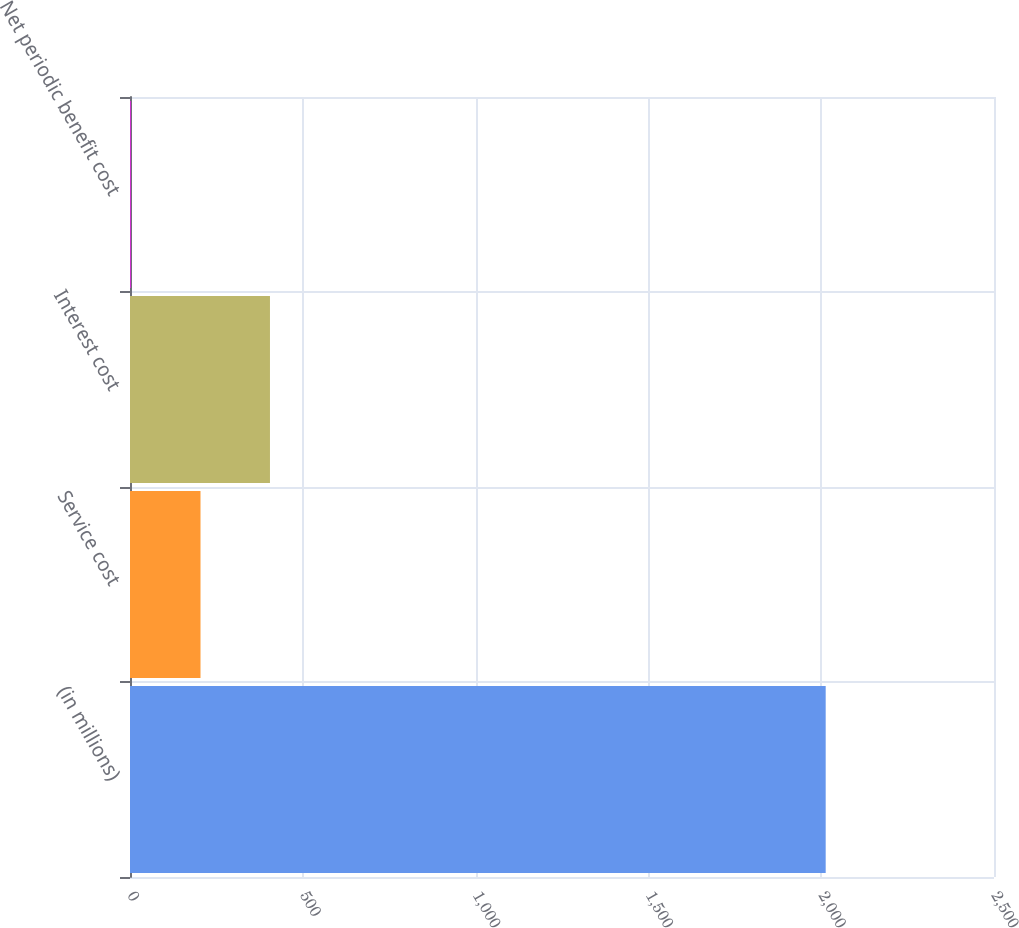<chart> <loc_0><loc_0><loc_500><loc_500><bar_chart><fcel>(in millions)<fcel>Service cost<fcel>Interest cost<fcel>Net periodic benefit cost<nl><fcel>2013<fcel>204<fcel>405<fcel>3<nl></chart> 